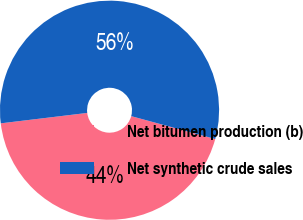Convert chart to OTSL. <chart><loc_0><loc_0><loc_500><loc_500><pie_chart><fcel>Net bitumen production (b)<fcel>Net synthetic crude sales<nl><fcel>43.86%<fcel>56.14%<nl></chart> 